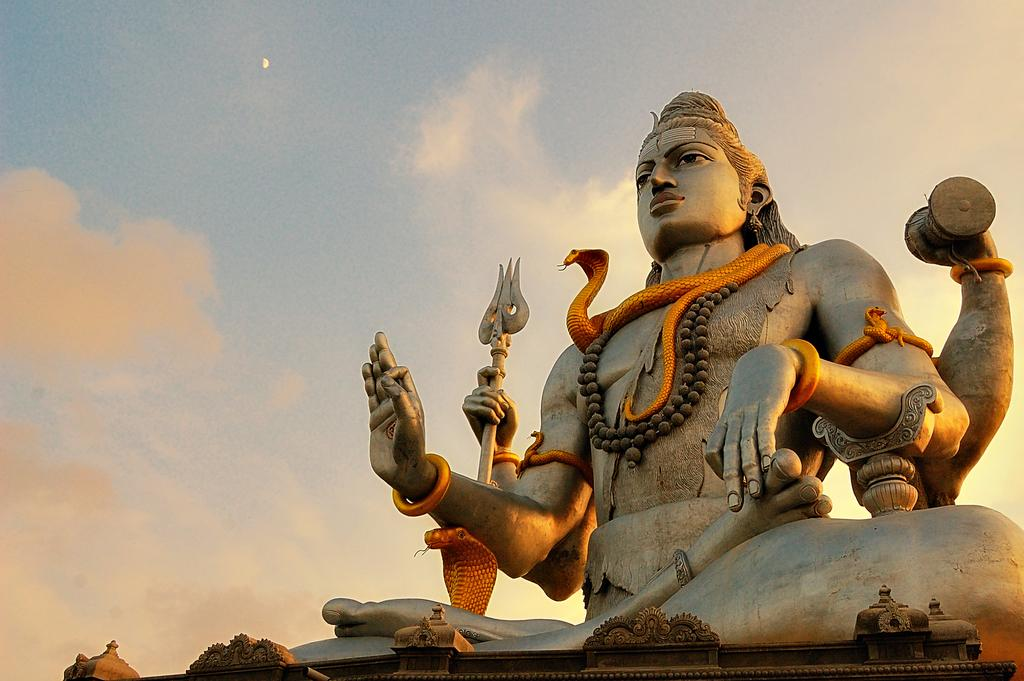What is the main subject in the middle of the image? There is a statue in the middle of the image. What can be seen in the sky in the image? Clouds are visible in the image, and the moon is observable in the sky. What type of cord is connected to the baby's car in the image? There is no baby, car, or cord present in the image. 